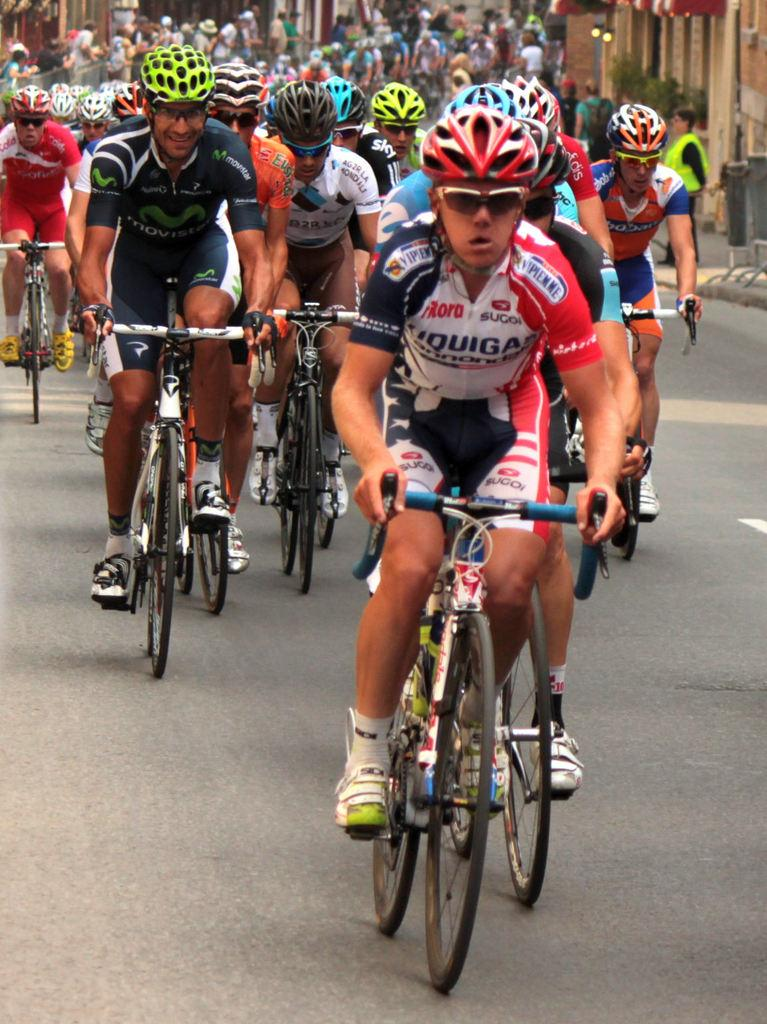What are the people in the image doing? The people in the image are riding bicycles. Where are the bicycles located? The bicycles are on the road. What can be seen on both sides of the image? There are buildings on both the left and right sides of the image. What type of vegetation is present in front of the buildings? There are trees in front of the buildings on both sides. What type of flesh can be seen hanging from the trees in the image? There is no flesh hanging from the trees in the image; it features people riding bicycles on the road with buildings and trees on both sides. 